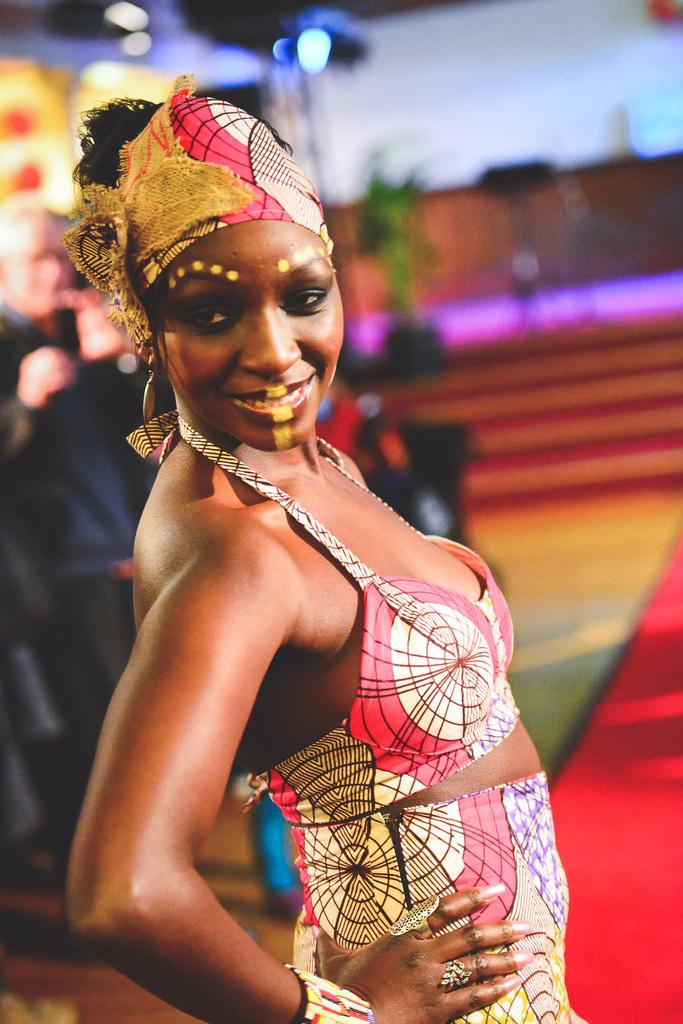What is the main subject of the image? There is a person standing in the image. Can you describe the person's attire? The person is wearing a dress with cream and red colors. What can be seen in the background of the image? There are lights and stairs visible in the background of the image. What type of seed is being planted by the person in the image? There is no seed or planting activity depicted in the image; the person is simply standing. How many people are present in the image, and what are they doing? There is only one person present in the image, and they are standing. 